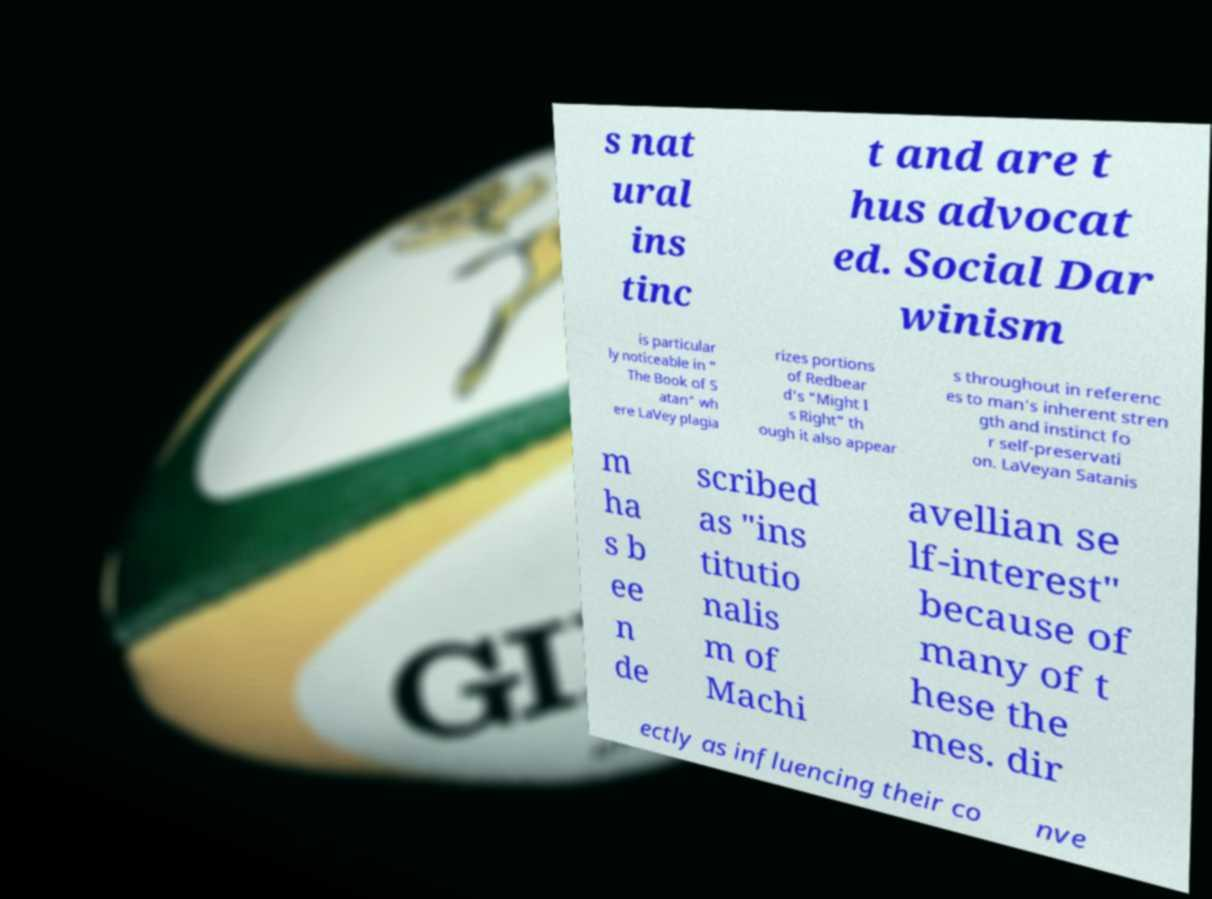Could you assist in decoding the text presented in this image and type it out clearly? s nat ural ins tinc t and are t hus advocat ed. Social Dar winism is particular ly noticeable in " The Book of S atan" wh ere LaVey plagia rizes portions of Redbear d's "Might I s Right" th ough it also appear s throughout in referenc es to man's inherent stren gth and instinct fo r self-preservati on. LaVeyan Satanis m ha s b ee n de scribed as "ins titutio nalis m of Machi avellian se lf-interest" because of many of t hese the mes. dir ectly as influencing their co nve 